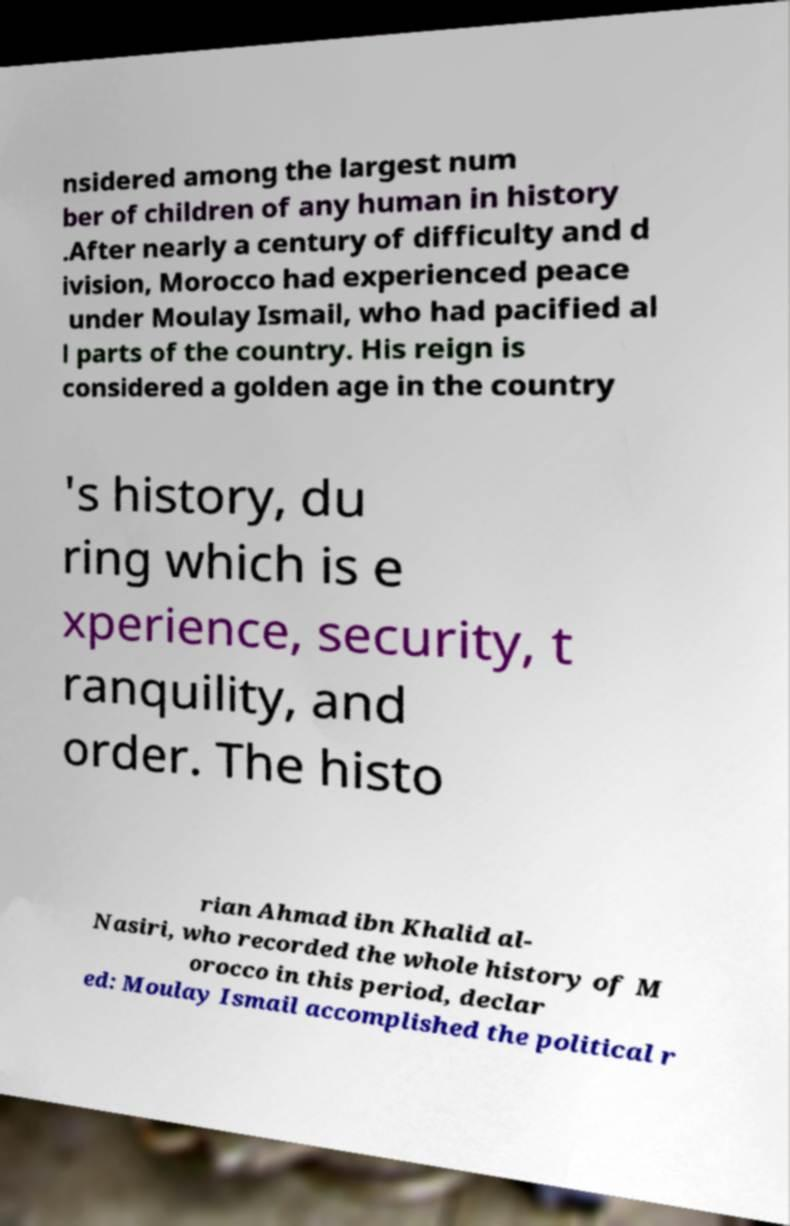Please identify and transcribe the text found in this image. nsidered among the largest num ber of children of any human in history .After nearly a century of difficulty and d ivision, Morocco had experienced peace under Moulay Ismail, who had pacified al l parts of the country. His reign is considered a golden age in the country 's history, du ring which is e xperience, security, t ranquility, and order. The histo rian Ahmad ibn Khalid al- Nasiri, who recorded the whole history of M orocco in this period, declar ed: Moulay Ismail accomplished the political r 